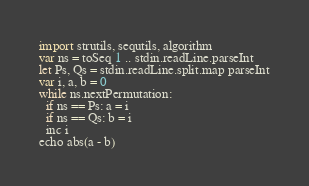Convert code to text. <code><loc_0><loc_0><loc_500><loc_500><_Nim_>import strutils, sequtils, algorithm
var ns = toSeq 1 .. stdin.readLine.parseInt
let Ps, Qs = stdin.readLine.split.map parseInt
var i, a, b = 0
while ns.nextPermutation:
  if ns == Ps: a = i
  if ns == Qs: b = i
  inc i
echo abs(a - b)</code> 